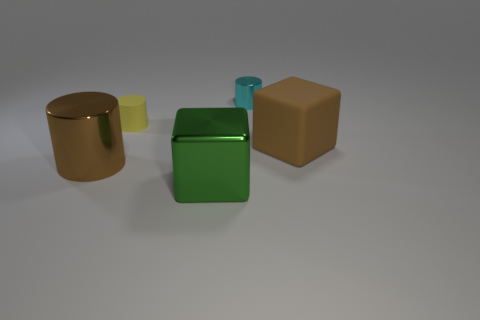Add 1 tiny objects. How many objects exist? 6 Subtract all cubes. How many objects are left? 3 Subtract all green matte cylinders. Subtract all tiny cyan cylinders. How many objects are left? 4 Add 2 big cylinders. How many big cylinders are left? 3 Add 4 tiny yellow matte things. How many tiny yellow matte things exist? 5 Subtract 0 cyan blocks. How many objects are left? 5 